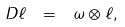Convert formula to latex. <formula><loc_0><loc_0><loc_500><loc_500>\ D \ell \ = \ \omega \otimes \ell ,</formula> 